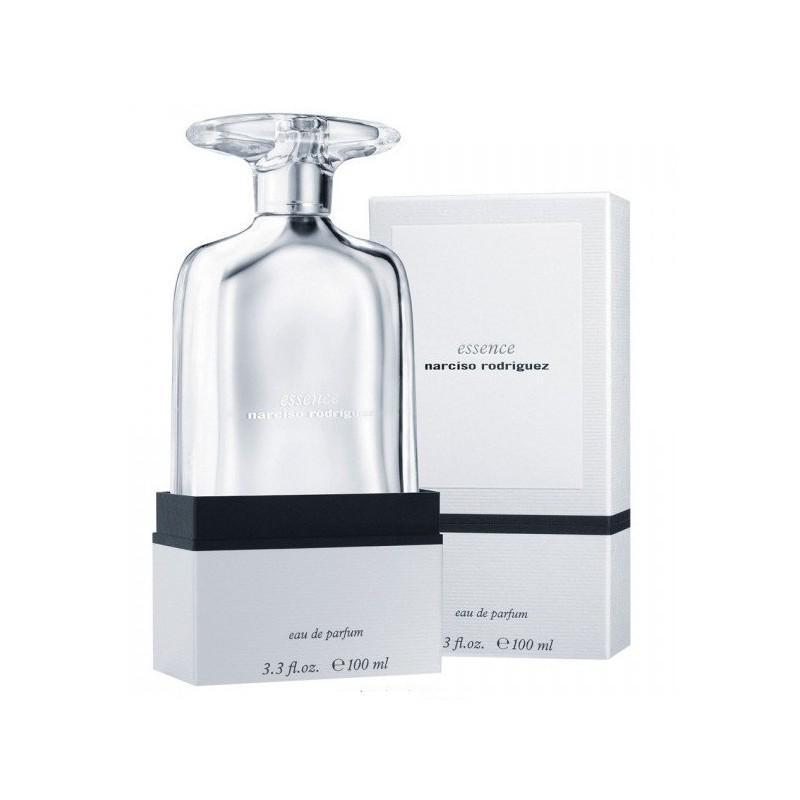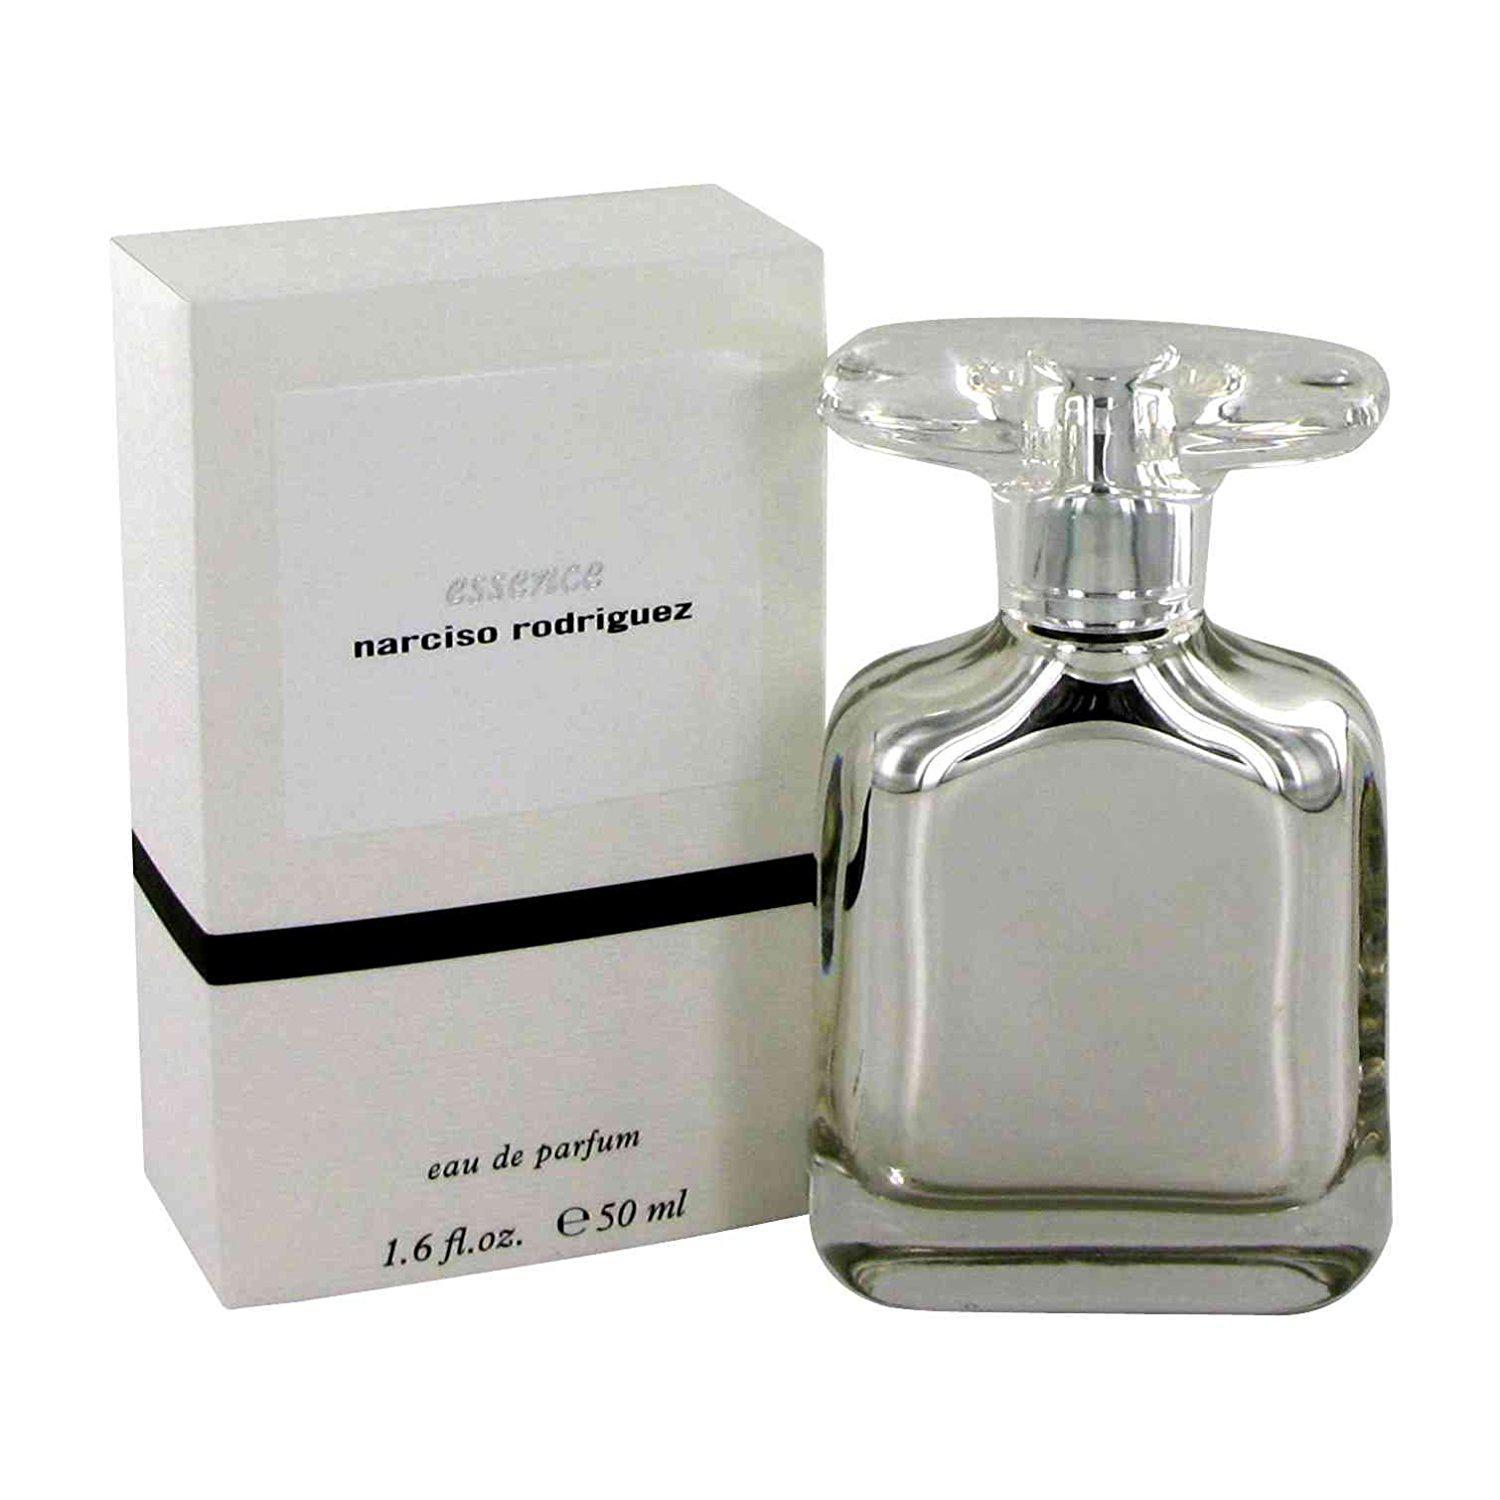The first image is the image on the left, the second image is the image on the right. Considering the images on both sides, is "The image on the right contains both a bottle and a box." valid? Answer yes or no. Yes. 